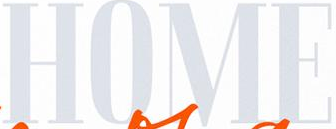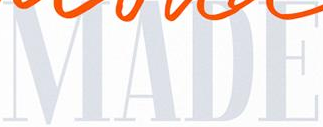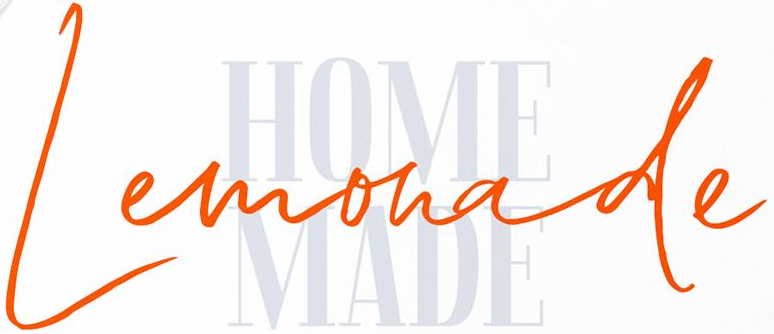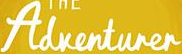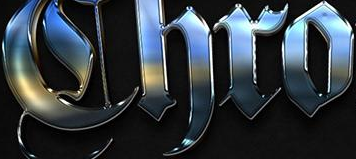Read the text content from these images in order, separated by a semicolon. HOME; MADE; Lemonade; Adventurer; Chro 